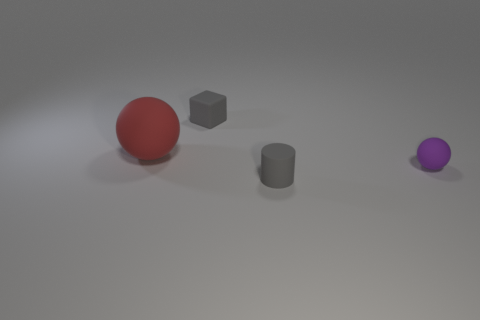How does the size of the red sphere compare to the other objects in the image? The red sphere is the largest object in the image when considering its overall dimensions. It dwarfs the two gray objects and the purple sphere, highlighting its prominence in the composition. 